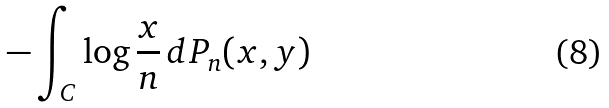Convert formula to latex. <formula><loc_0><loc_0><loc_500><loc_500>- \int _ { C } \log \frac { x } { n } \, d P _ { n } ( x , y )</formula> 